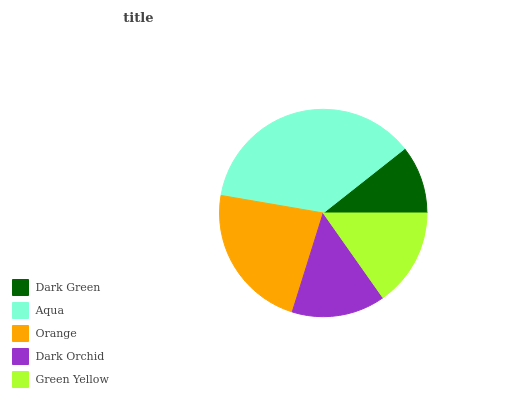Is Dark Green the minimum?
Answer yes or no. Yes. Is Aqua the maximum?
Answer yes or no. Yes. Is Orange the minimum?
Answer yes or no. No. Is Orange the maximum?
Answer yes or no. No. Is Aqua greater than Orange?
Answer yes or no. Yes. Is Orange less than Aqua?
Answer yes or no. Yes. Is Orange greater than Aqua?
Answer yes or no. No. Is Aqua less than Orange?
Answer yes or no. No. Is Green Yellow the high median?
Answer yes or no. Yes. Is Green Yellow the low median?
Answer yes or no. Yes. Is Dark Green the high median?
Answer yes or no. No. Is Aqua the low median?
Answer yes or no. No. 